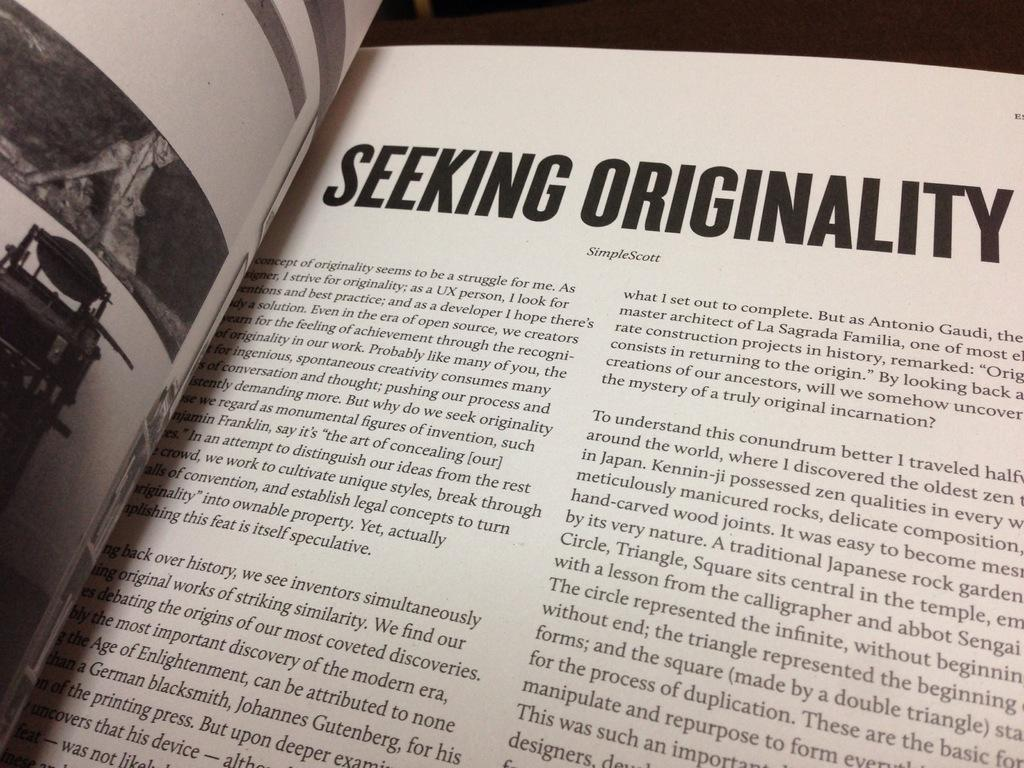<image>
Write a terse but informative summary of the picture. An open book with the headline Seeking Originality on it. 